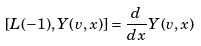Convert formula to latex. <formula><loc_0><loc_0><loc_500><loc_500>[ L ( - 1 ) , Y ( v , x ) ] = \frac { d } { d x } Y ( v , x )</formula> 